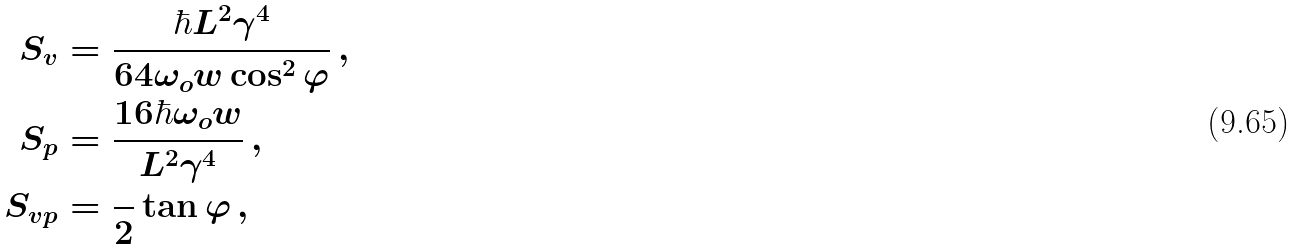Convert formula to latex. <formula><loc_0><loc_0><loc_500><loc_500>S _ { v } & = \frac { \hbar { L } ^ { 2 } \gamma ^ { 4 } } { 6 4 \omega _ { o } w \cos ^ { 2 } \varphi } \, , \\ S _ { p } & = \frac { 1 6 \hbar { \omega } _ { o } w } { L ^ { 2 } \gamma ^ { 4 } } \, , \\ S _ { v p } & = \frac { } { 2 } \tan \varphi \, ,</formula> 